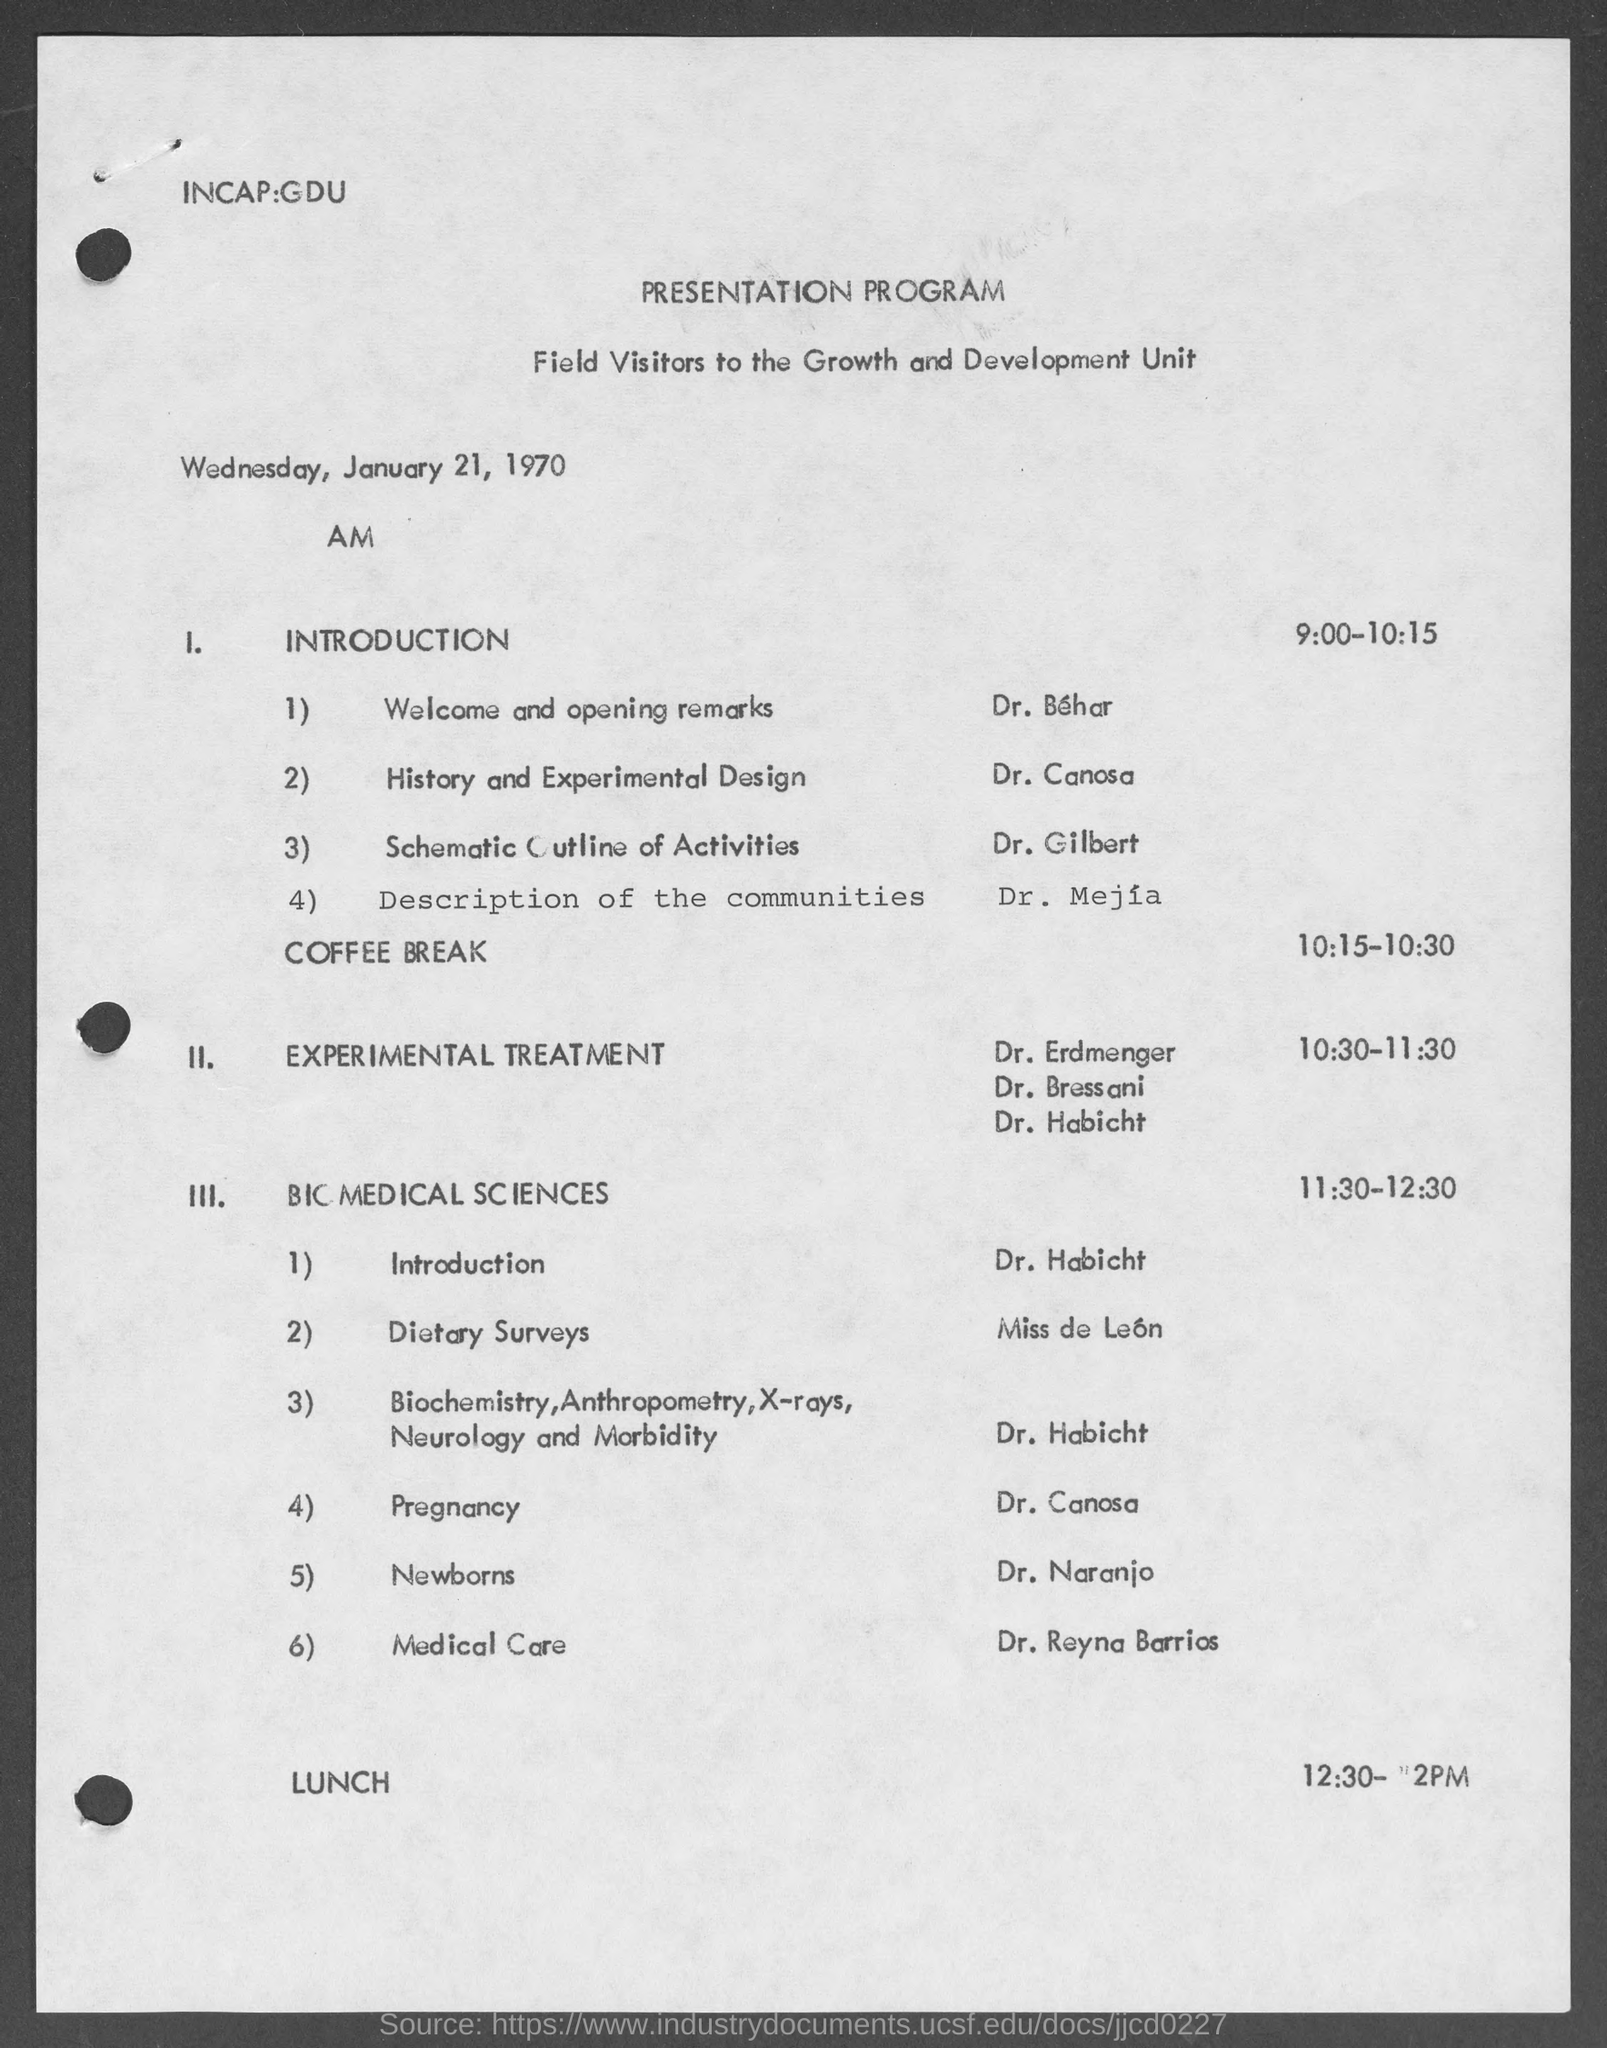Indicate a few pertinent items in this graphic. The title at the top of the page is "A Presentation Program. The entity responsible for providing the Schematic Outline of Activities is Dr. Gilbert. The identity of the individual providing history and experimental design is Dr. Canosa. 